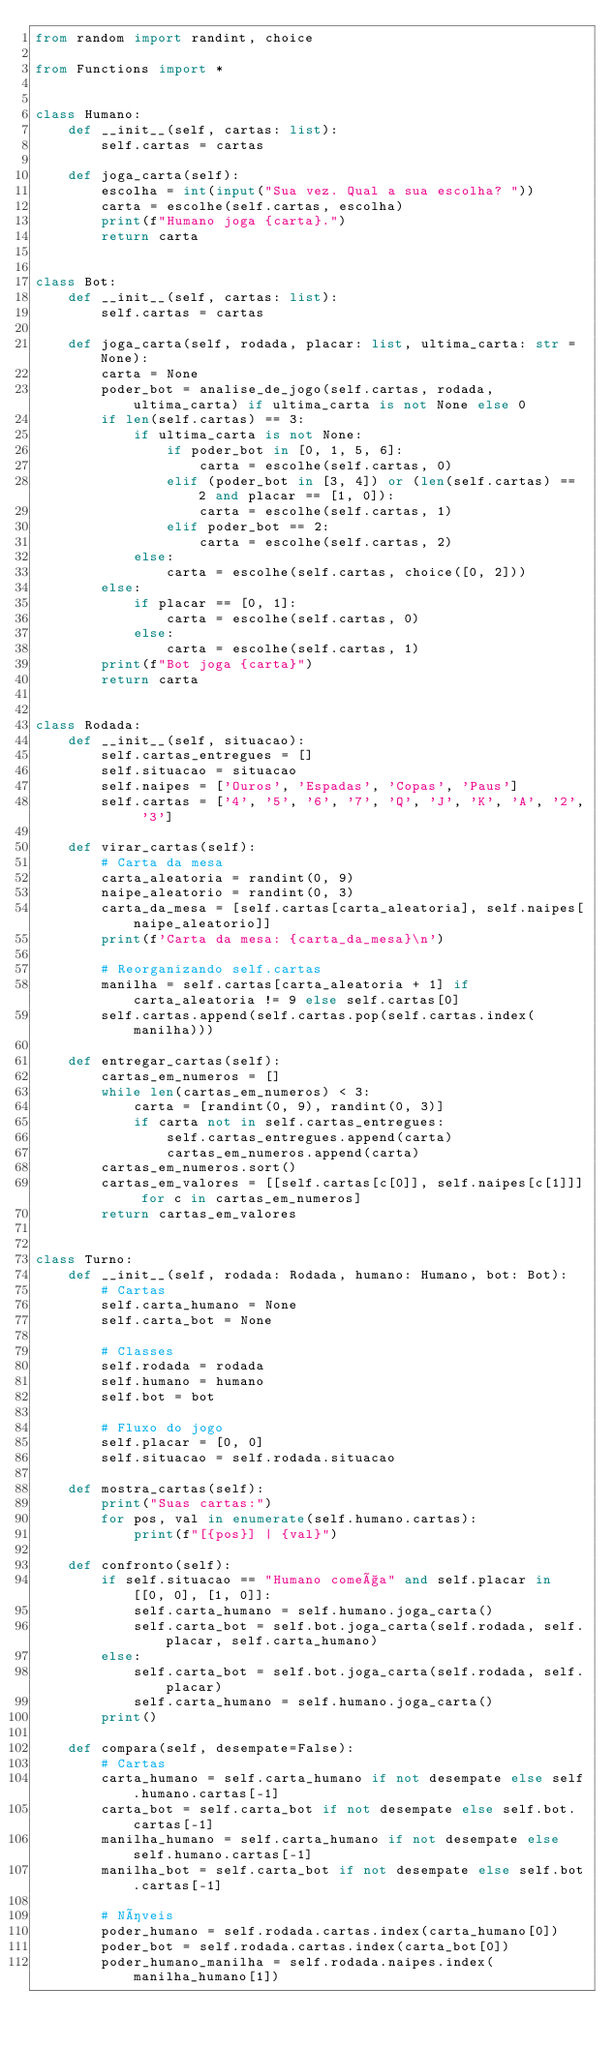Convert code to text. <code><loc_0><loc_0><loc_500><loc_500><_Python_>from random import randint, choice

from Functions import *


class Humano:
    def __init__(self, cartas: list):
        self.cartas = cartas

    def joga_carta(self):
        escolha = int(input("Sua vez. Qual a sua escolha? "))
        carta = escolhe(self.cartas, escolha)
        print(f"Humano joga {carta}.")
        return carta


class Bot:
    def __init__(self, cartas: list):
        self.cartas = cartas

    def joga_carta(self, rodada, placar: list, ultima_carta: str = None):
        carta = None
        poder_bot = analise_de_jogo(self.cartas, rodada, ultima_carta) if ultima_carta is not None else 0
        if len(self.cartas) == 3:
            if ultima_carta is not None:
                if poder_bot in [0, 1, 5, 6]:
                    carta = escolhe(self.cartas, 0)
                elif (poder_bot in [3, 4]) or (len(self.cartas) == 2 and placar == [1, 0]):
                    carta = escolhe(self.cartas, 1)
                elif poder_bot == 2:
                    carta = escolhe(self.cartas, 2)
            else:
                carta = escolhe(self.cartas, choice([0, 2]))
        else:
            if placar == [0, 1]:
                carta = escolhe(self.cartas, 0)
            else:
                carta = escolhe(self.cartas, 1)
        print(f"Bot joga {carta}")
        return carta


class Rodada:
    def __init__(self, situacao):
        self.cartas_entregues = []
        self.situacao = situacao
        self.naipes = ['Ouros', 'Espadas', 'Copas', 'Paus']
        self.cartas = ['4', '5', '6', '7', 'Q', 'J', 'K', 'A', '2', '3']

    def virar_cartas(self):
        # Carta da mesa
        carta_aleatoria = randint(0, 9)
        naipe_aleatorio = randint(0, 3)
        carta_da_mesa = [self.cartas[carta_aleatoria], self.naipes[naipe_aleatorio]]
        print(f'Carta da mesa: {carta_da_mesa}\n')

        # Reorganizando self.cartas
        manilha = self.cartas[carta_aleatoria + 1] if carta_aleatoria != 9 else self.cartas[0]
        self.cartas.append(self.cartas.pop(self.cartas.index(manilha)))

    def entregar_cartas(self):
        cartas_em_numeros = []
        while len(cartas_em_numeros) < 3:
            carta = [randint(0, 9), randint(0, 3)]
            if carta not in self.cartas_entregues:
                self.cartas_entregues.append(carta)
                cartas_em_numeros.append(carta)
        cartas_em_numeros.sort()
        cartas_em_valores = [[self.cartas[c[0]], self.naipes[c[1]]] for c in cartas_em_numeros]
        return cartas_em_valores


class Turno:
    def __init__(self, rodada: Rodada, humano: Humano, bot: Bot):
        # Cartas
        self.carta_humano = None
        self.carta_bot = None

        # Classes
        self.rodada = rodada
        self.humano = humano
        self.bot = bot

        # Fluxo do jogo
        self.placar = [0, 0]
        self.situacao = self.rodada.situacao

    def mostra_cartas(self):
        print("Suas cartas:")
        for pos, val in enumerate(self.humano.cartas):
            print(f"[{pos}] | {val}")

    def confronto(self):
        if self.situacao == "Humano começa" and self.placar in [[0, 0], [1, 0]]:
            self.carta_humano = self.humano.joga_carta()
            self.carta_bot = self.bot.joga_carta(self.rodada, self.placar, self.carta_humano)
        else:
            self.carta_bot = self.bot.joga_carta(self.rodada, self.placar)
            self.carta_humano = self.humano.joga_carta()
        print()

    def compara(self, desempate=False):
        # Cartas
        carta_humano = self.carta_humano if not desempate else self.humano.cartas[-1]
        carta_bot = self.carta_bot if not desempate else self.bot.cartas[-1]
        manilha_humano = self.carta_humano if not desempate else self.humano.cartas[-1]
        manilha_bot = self.carta_bot if not desempate else self.bot.cartas[-1]

        # Níveis
        poder_humano = self.rodada.cartas.index(carta_humano[0])
        poder_bot = self.rodada.cartas.index(carta_bot[0])
        poder_humano_manilha = self.rodada.naipes.index(manilha_humano[1])</code> 